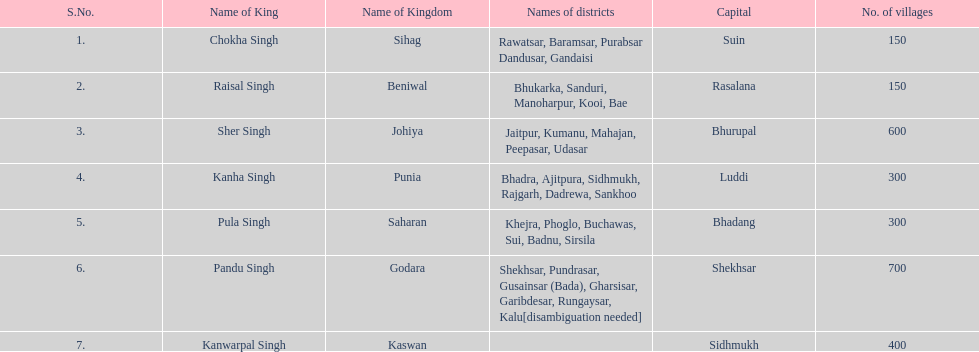Which kingdom contained the second most villages, next only to godara? Johiya. 